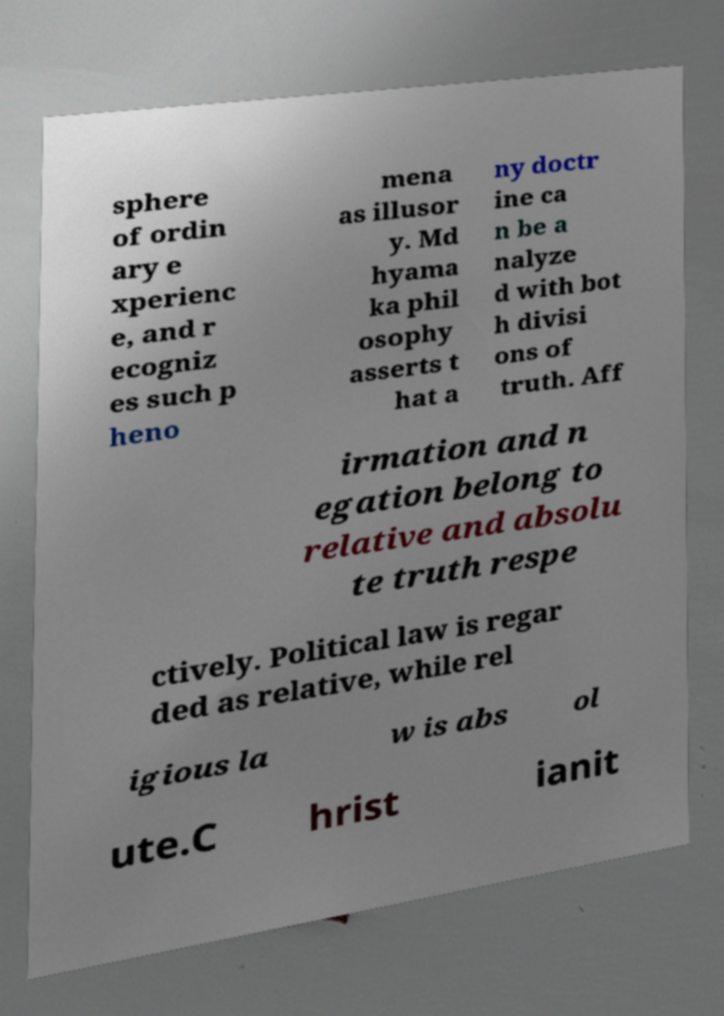Can you accurately transcribe the text from the provided image for me? sphere of ordin ary e xperienc e, and r ecogniz es such p heno mena as illusor y. Md hyama ka phil osophy asserts t hat a ny doctr ine ca n be a nalyze d with bot h divisi ons of truth. Aff irmation and n egation belong to relative and absolu te truth respe ctively. Political law is regar ded as relative, while rel igious la w is abs ol ute.C hrist ianit 